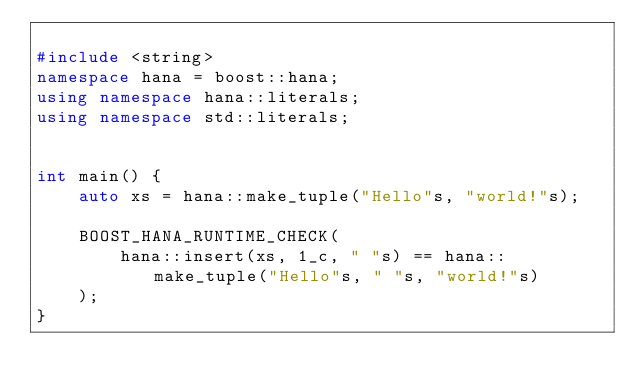<code> <loc_0><loc_0><loc_500><loc_500><_C++_>
#include <string>
namespace hana = boost::hana;
using namespace hana::literals;
using namespace std::literals;


int main() {
    auto xs = hana::make_tuple("Hello"s, "world!"s);

    BOOST_HANA_RUNTIME_CHECK(
        hana::insert(xs, 1_c, " "s) == hana::make_tuple("Hello"s, " "s, "world!"s)
    );
}
</code> 